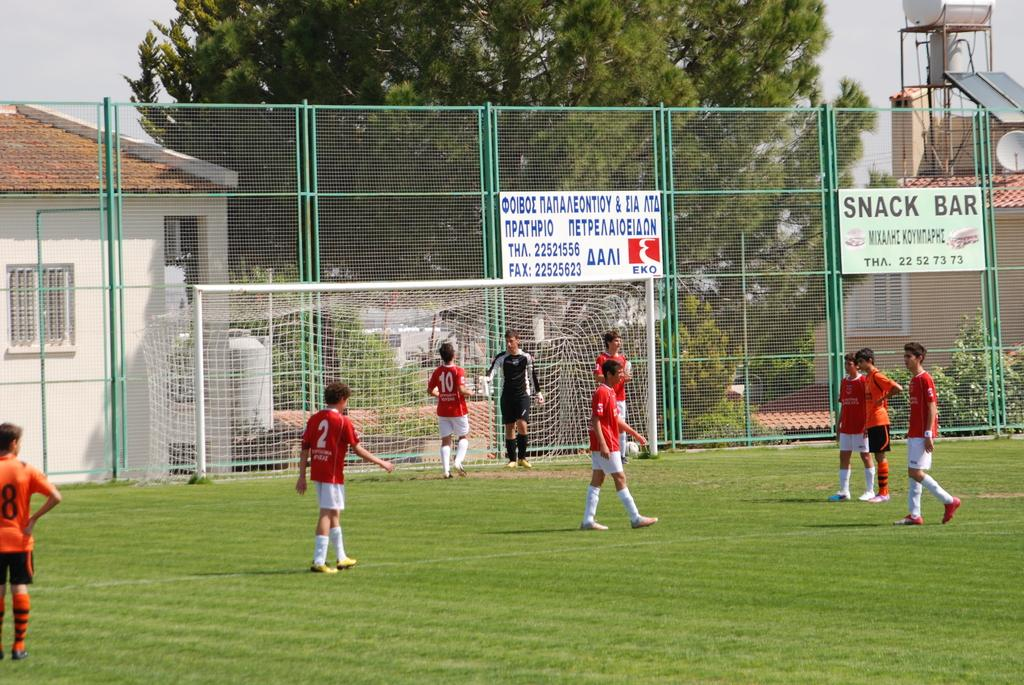Provide a one-sentence caption for the provided image. A group of soccer players mill around the field before a game in front of a fence with an ad for the Snack Bar on it. 